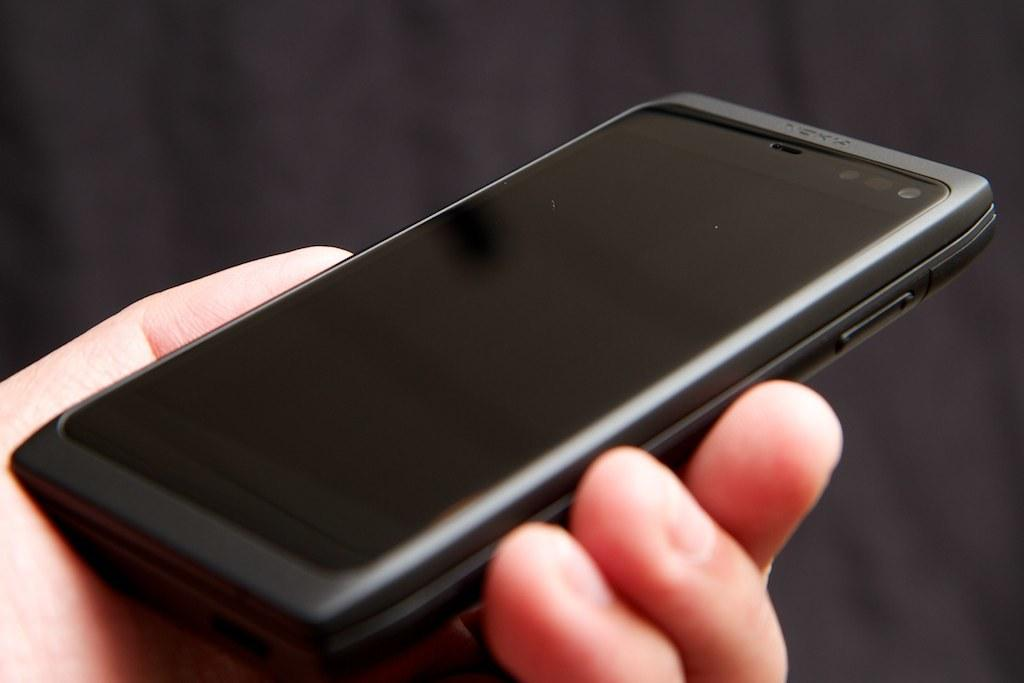What object is being held by a human in the image? There is a mobile in the image, and it is being held by a human. Can you describe the background of the image? The background of the image is dark. How many bears can be seen in the image? There are no bears present in the image. What type of knee support is visible in the image? There is no knee support visible in the image. 